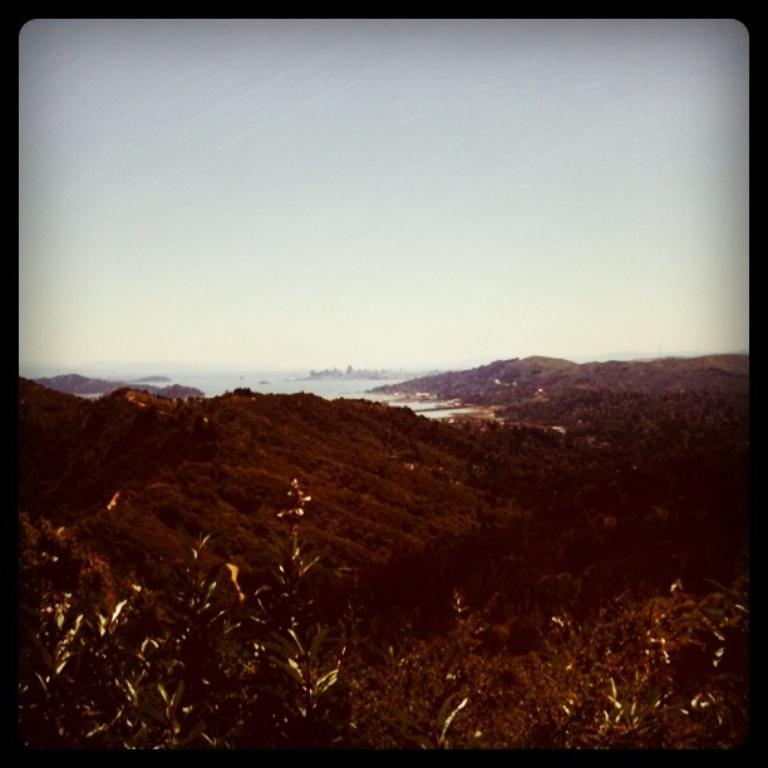What celestial bodies are shown at the bottom of the image? There are planets depicted at the bottom of the image. What type of environment is suggested by the background? The background appears to contain water, suggesting a watery or aquatic environment. What is visible at the top of the image? The sky is visible at the top of the image. Where is the glove placed in the image? There is no glove present in the image. What type of jewel can be seen in the image? There are no jewels present in the image. 